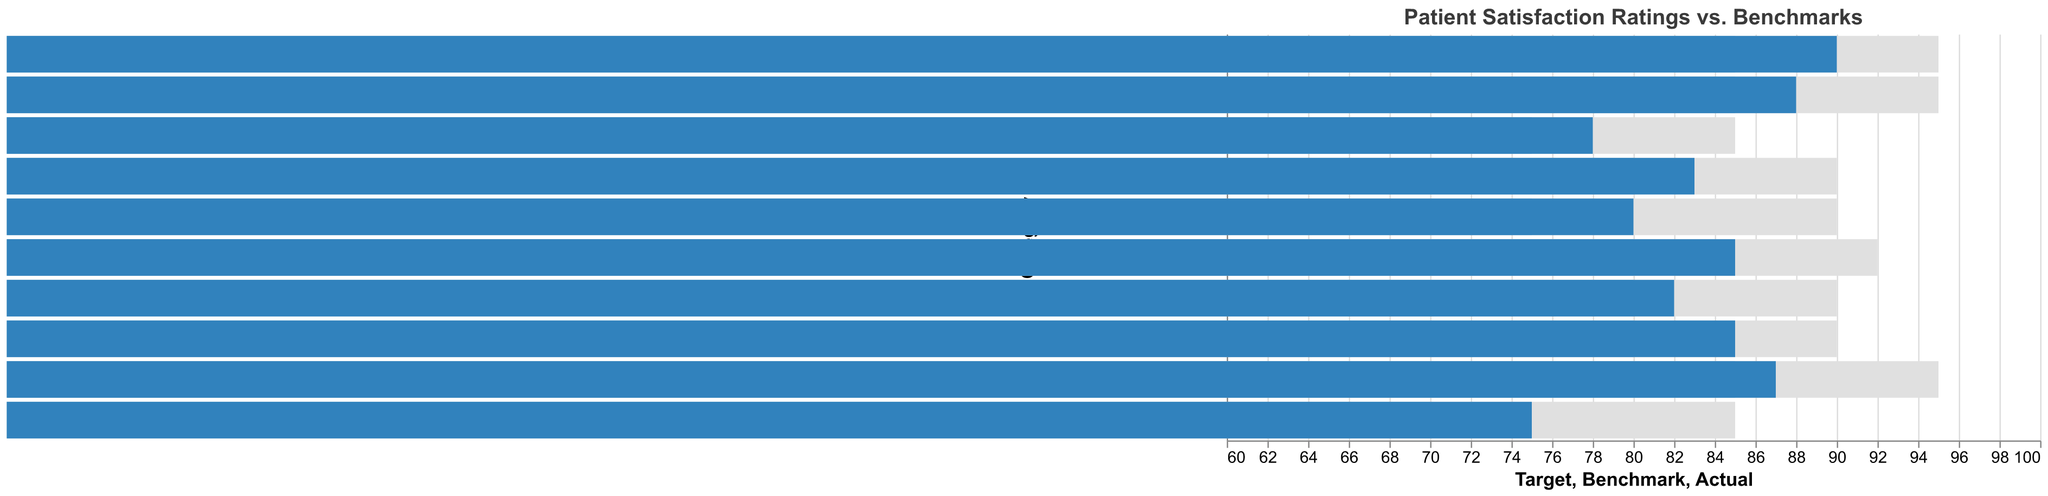What's the highest satisfaction rating achieved? The highest satisfaction rating is located by examining the Actual column. The highest number in this column is 90, corresponding to Cleanliness.
Answer: 90 What is the target rating for Doctor Communication? Look at the Target column and locate the value corresponding to Doctor Communication. The entry under the Target column is 95.
Answer: 95 Which category has the largest gap between Actual and Target ratings? Calculate the difference between the Actual and Target ratings for each category and find the largest gap. Wait Time has a difference of 10 (85 - 75), which is the largest gap.
Answer: Wait Time What are the Actual ratings for Overall Satisfaction and Nurse Care, and how do they compare? The Actual rating for Overall Satisfaction is 85, and for Nurse Care, it is 82. Comparing them, Overall Satisfaction has a higher rating than Nurse Care.
Answer: 85 and 82, Overall Satisfaction is higher How many categories have Actual ratings that meet or exceed their Benchmark ratings? Check how many categories have Actual ratings greater than or equal to their Benchmark ratings. Comparing these, all categories meet or exceed their Benchmark ratings.
Answer: 10 categories Which category shows the smallest difference between the Actual and Benchmark ratings? Calculate the difference between the Actual and Benchmark ratings. The smallest difference is for Follow-up Care with a difference of 5 (80 - 75).
Answer: Follow-up Care Does any category achieve the Target rating exactly? Check the Actual ratings to see if any match exactly with their Target ratings. Cleanliness has an Actual rating of 90, which matches its Target rating.
Answer: Cleanliness What is the average Target rating across all categories? Sum up all the Target ratings and divide by the number of categories. (90 + 85 + 95 + 90 + 95 + 85 + 90 + 92 + 95 + 90) / 10 = 90.7
Answer: 90.7 Which category has an Actual rating lower than both its Benchmark and Target? Compare Actual, Benchmark, and Target ratings for each category. Wait Time has an Actual rating (75) lower than both its Benchmark (70) and Target (85).
Answer: Wait Time What is the difference between the highest and the lowest Actual ratings? Identify the highest and lowest values in the Actual ratings column. The highest is 90 (Cleanliness), and the lowest is 75 (Wait Time). The difference is 90 - 75 = 15.
Answer: 15 